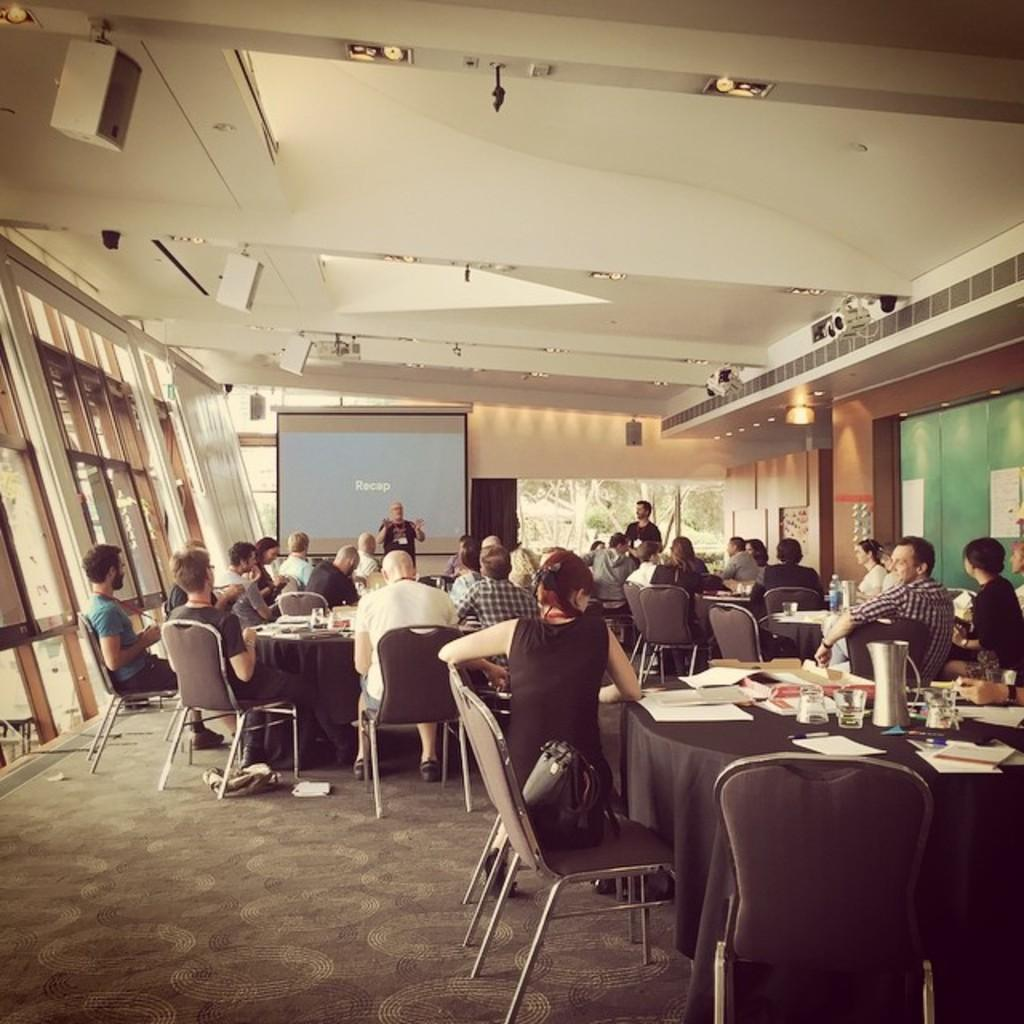What device is the main focus of the image? There is a projector in the image. Can you describe the people in the image? There are people in the image, but their specific actions or roles are not mentioned in the facts. What type of furniture is present in the image? Chairs and tables are visible in the image. What might the people be using the projector for? The presence of papers suggests that the projector might be used for a presentation or educational purpose. What type of lighting is present in the image? Lights are present in the image. What part of the room can be seen in the image? The ceiling is visible in the image. What other objects are present in the image? The facts mention that there are other objects in the image, but their specific nature is not described. What type of drum is being played in the image? There is no drum present in the image; the main focus is on the projector. 